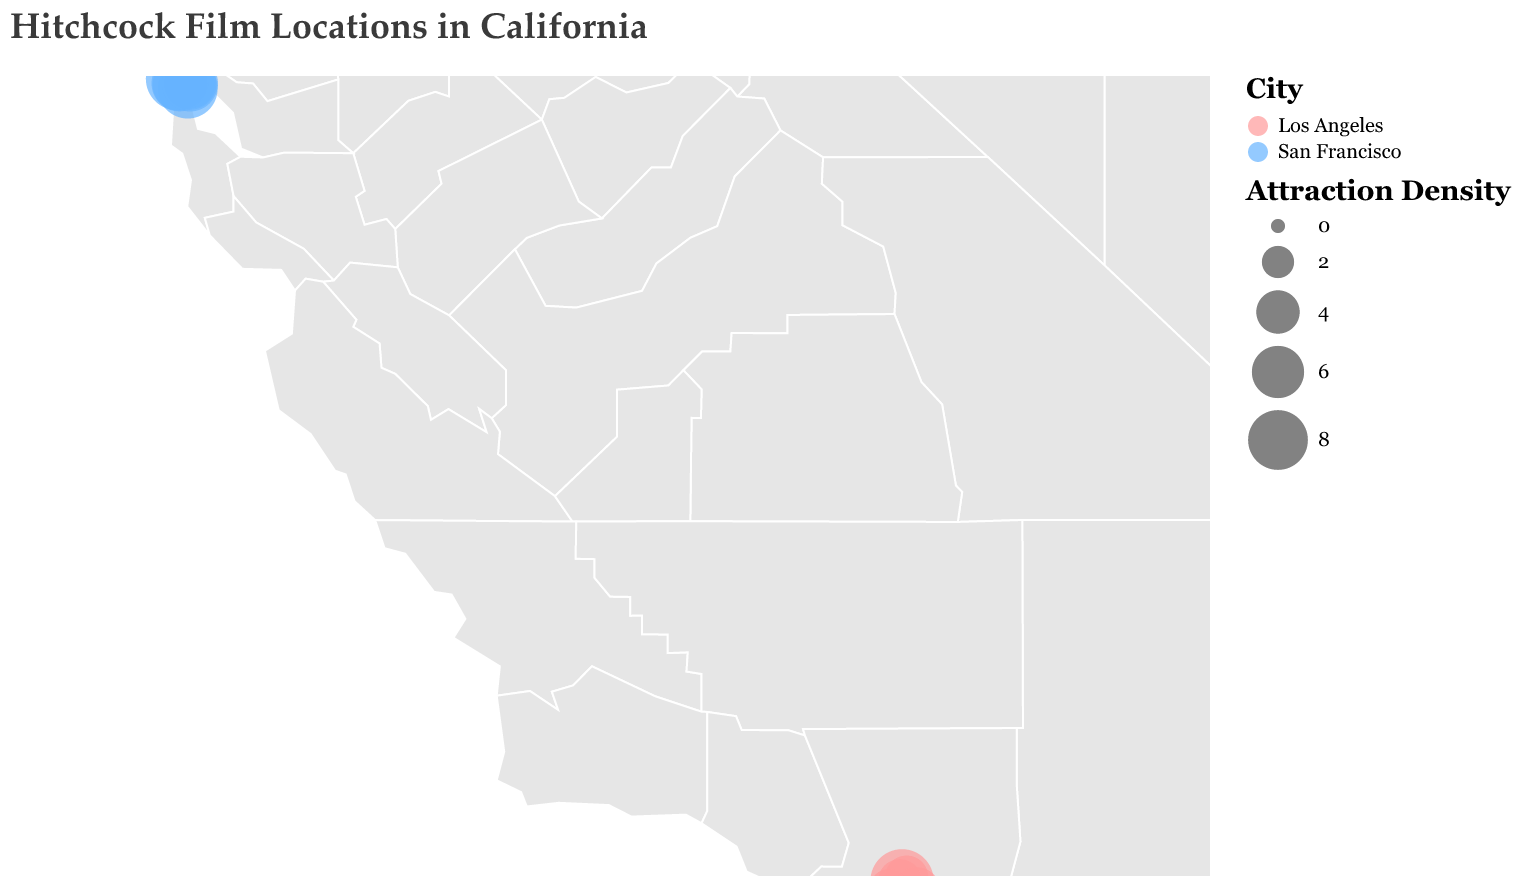Which city has the highest density score for a single attraction? By observing the size of the circles, the circle in Los Angeles (Psycho House at Universal Studios) appears the largest. Its Density Score is 9, which is higher than any other data points in the figure.
Answer: Los Angeles How many attractions are located in San Francisco according to the plot? By counting the number of data points labeled "San Francisco," we observe there are 7 attractions indicated on the map.
Answer: 7 What is the average Density Score of attractions in Los Angeles? Los Angeles has five attractions with Density Scores of 9, 5, 4, 3, 4. Adding these gives a total of 25. Dividing by the number of attractions (5), the average Density Score is 5.
Answer: 5 Which attraction has the highest Density Score in San Francisco? In San Francisco, the Golden Gate Bridge (Vertigo) has a Density Score of 9, which is the highest among the data points in that city.
Answer: Golden Gate Bridge (Vertigo) How does the Density Score of Vertigo's Brocklebank Apartments compare to Fort Point? Both locations are in San Francisco. Fort Point has a Density Score of 7 while Vertigo's Brocklebank Apartments has a Density Score of 8. Thus, Vertigo's Brocklebank Apartments has a higher Density Score by 1.
Answer: Vertigo's Brocklebank Apartments is higher What is the sum of all Density Scores for attractions in San Francisco? Adding up the Density Scores: 8 (Brocklebank Apartments) + 7 (Fort Point) + 6 (Coit Tower) + 6 (Palace of Fine Arts) + 9 (Golden Gate Bridge) + 5 (Cafe Trieste) + 7 (Legion of Honor) gives a total of 48.
Answer: 48 Which city has the greater overall number of attractions? By counting the data points labeled "San Francisco" and "Los Angeles," we see San Francisco has 7 attractions, while Los Angeles has 5. Therefore, San Francisco has the greater number.
Answer: San Francisco Is there a significant difference in the average Density Score between San Francisco and Los Angeles? The average Density Score of San Francisco is calculated by dividing the sum of its scores (48) by the number of attractions (7), giving approximately 6.86. The average for Los Angeles is 5. The difference is 6.86 - 5 = 1.86, which indicates a moderate difference.
Answer: Approximately 1.86 higher in San Francisco Which city features more prominently in Vertigo film locations based on the number of attractions? Observing the locations associated with "Vertigo" listed in San Francisco, we find Brocklebank Apartments, Fort Point, Coit Tower, Palace of Fine Arts, Golden Gate Bridge, and Legion of Honor, giving a total of 6. Therefore, San Francisco features more prominently for Vertigo film locations.
Answer: San Francisco 